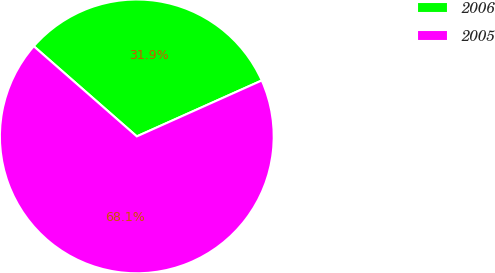Convert chart. <chart><loc_0><loc_0><loc_500><loc_500><pie_chart><fcel>2006<fcel>2005<nl><fcel>31.86%<fcel>68.14%<nl></chart> 